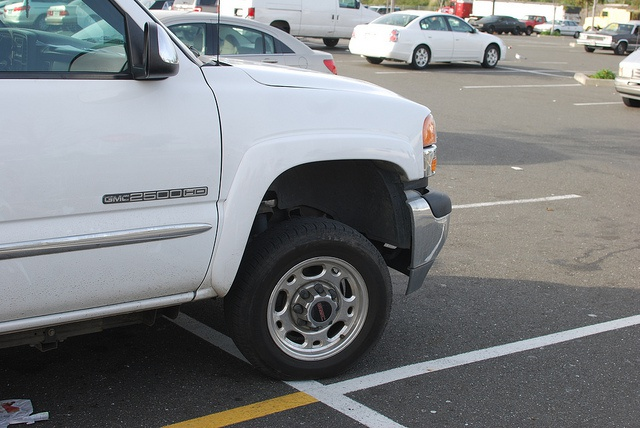Describe the objects in this image and their specific colors. I can see truck in teal, lightgray, black, darkgray, and gray tones, car in teal, lightgray, darkgray, black, and gray tones, car in teal, darkgray, gray, and lightgray tones, car in teal, lightgray, and darkgray tones, and car in teal, white, gray, darkgray, and black tones in this image. 